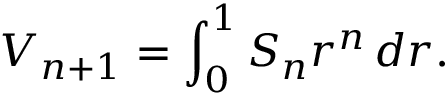<formula> <loc_0><loc_0><loc_500><loc_500>V _ { n + 1 } = \int _ { 0 } ^ { 1 } S _ { n } r ^ { n } \, d r .</formula> 